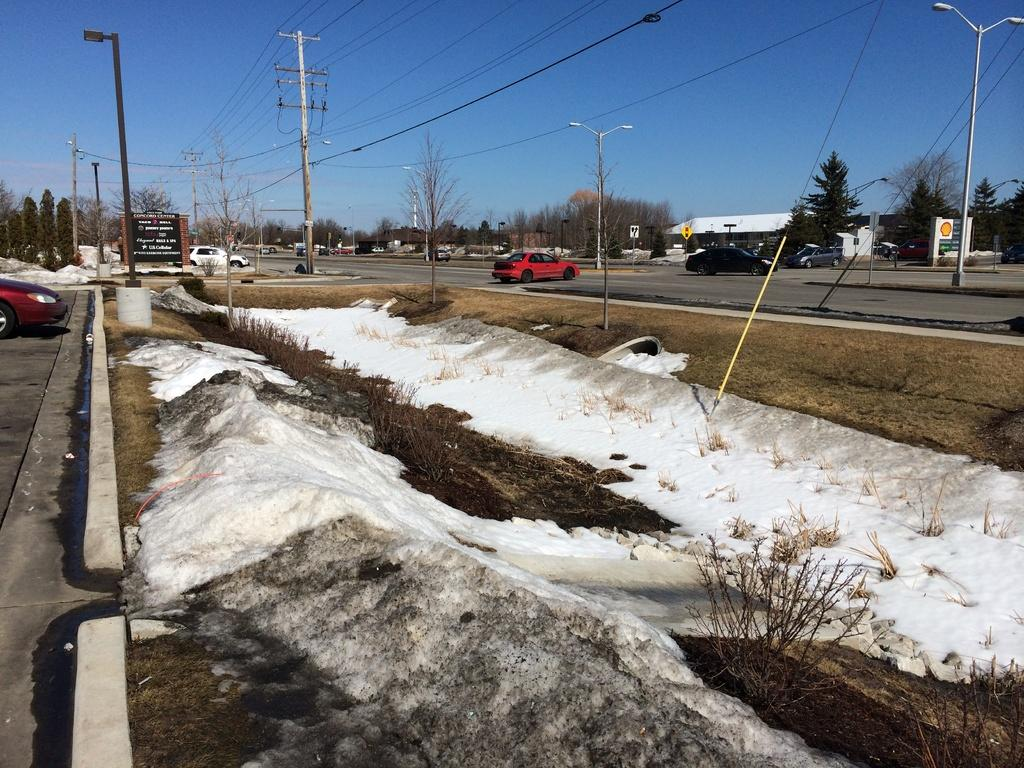What type of vegetation can be seen in the image? There are trees in the image. What structures are present in the image? There are poles in the image. What is covering the ground in the image? There is snow at the bottom of the image. What type of vehicles can be seen in the image? Cars are visible on the road. What objects are present in the image that are not related to trees, poles, snow, or cars? There are boards in the image. What can be seen in the background of the image? The sky is visible in the background of the image. Where is the pocket located in the image? There is no pocket present in the image. What type of wall can be seen in the image? There is no wall present in the image. 